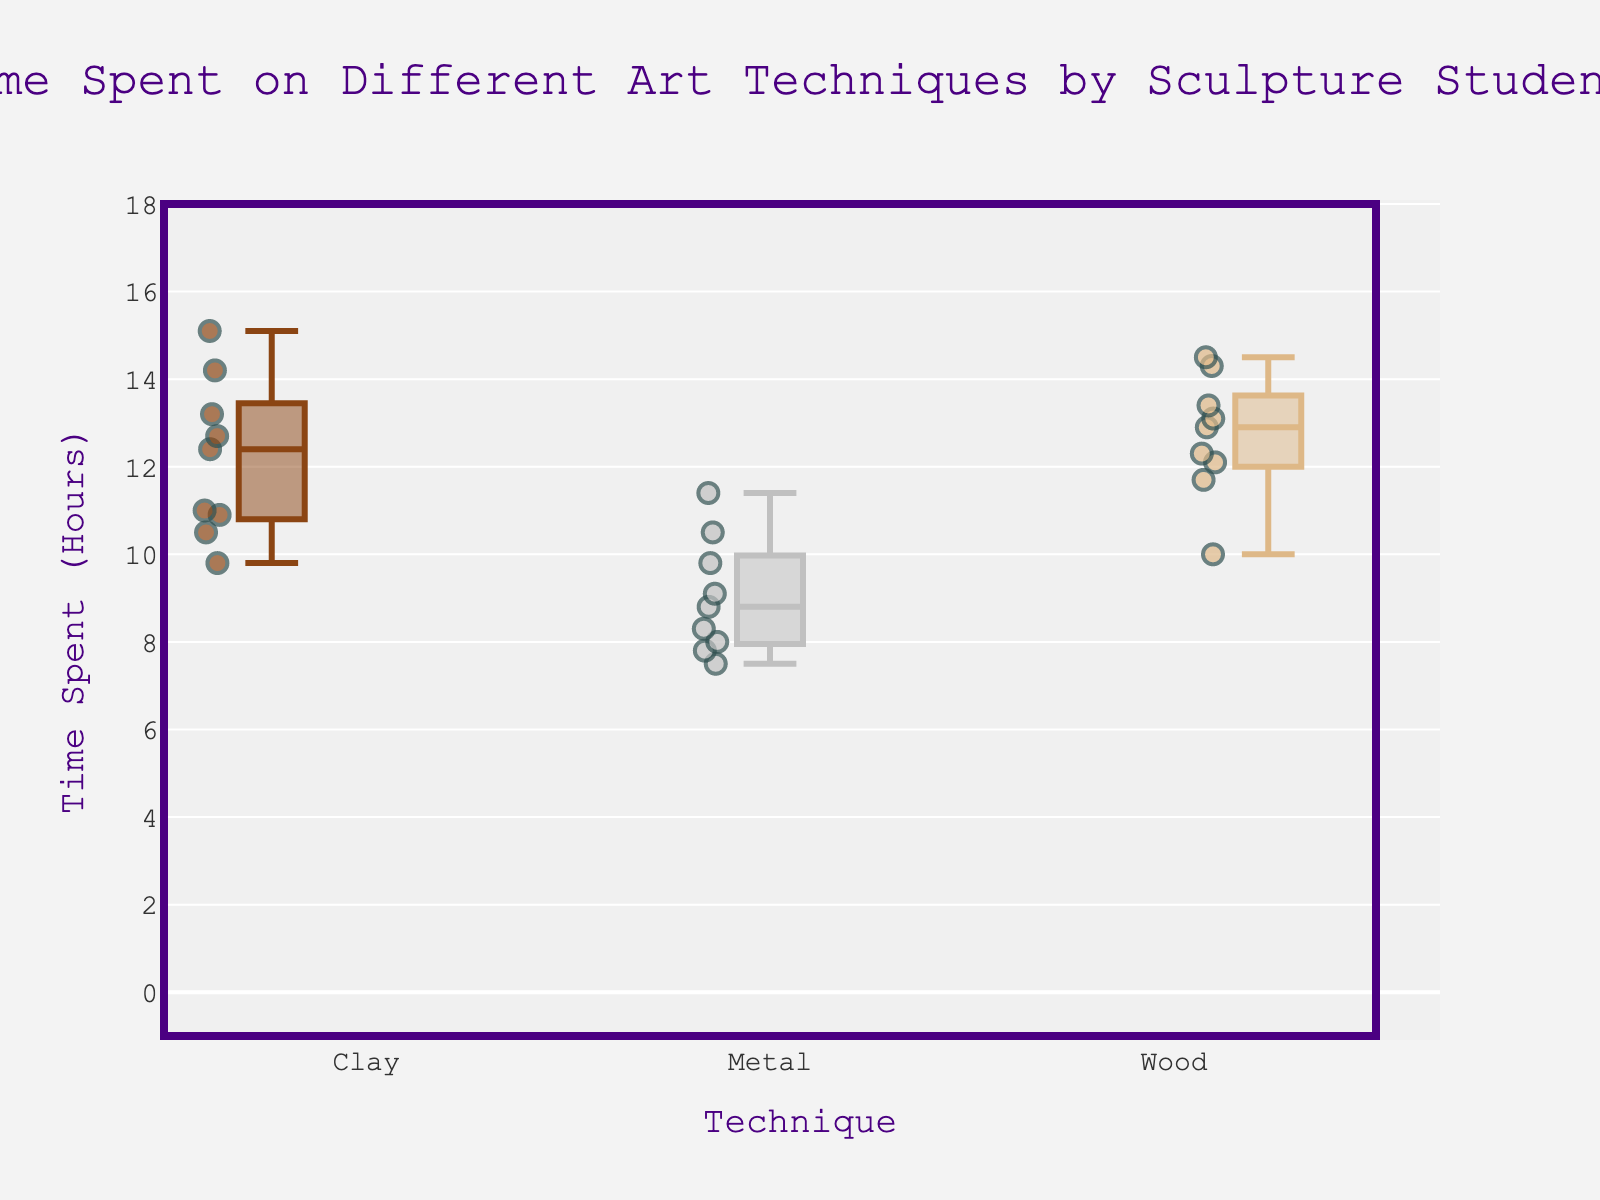How many different techniques are represented in the figure? The figure has three distinct color-coded boxes for different techniques.
Answer: 3 What is the title of the figure? The title is centered at the top of the figure, above the box plots.
Answer: Time Spent on Different Art Techniques by Sculpture Students Which technique has the highest median time spent? Identify the middle value of the boxes for each technique by looking at the line within the box.
Answer: Clay What are the names of the students who spent the most and least time on Clay? Check the highest and lowest scatter points on the Clay box. Then, look up their names in hover data.
Answer: Henry Wright and Catherine Lee Compare the time spent on Metal and Wood techniques. Which has a higher range? The range is the difference between the maximum and minimum values. Look at the whiskers of the boxes.
Answer: Wood What is the median time spent on Metal? Identify the middle line within the Metal box.
Answer: About 8.8 hours If you summed up the median times for all three techniques, what is the total? First, identify the median time for each technique (Clay, Metal, Wood). Then, sum them.
Answer: Approximately 10.5 + 8.8 + 12.9 = 32.2 hours How many students spent more than 12 hours on Wood? Count the scatter points above 12 hours on the Wood box plot.
Answer: 5 Which technique shows the least variability in time spent? Variability is represented by the box size and whisker length. The smallest box with shortest whiskers indicates least variability.
Answer: Metal How does the time spent on Metal by Bob Smith compare to the median time of Metal? Find Bob Smith’s scatter point for Metal, and compare its position relative to the median line of the Metal box.
Answer: Bob Smith spent slightly less 